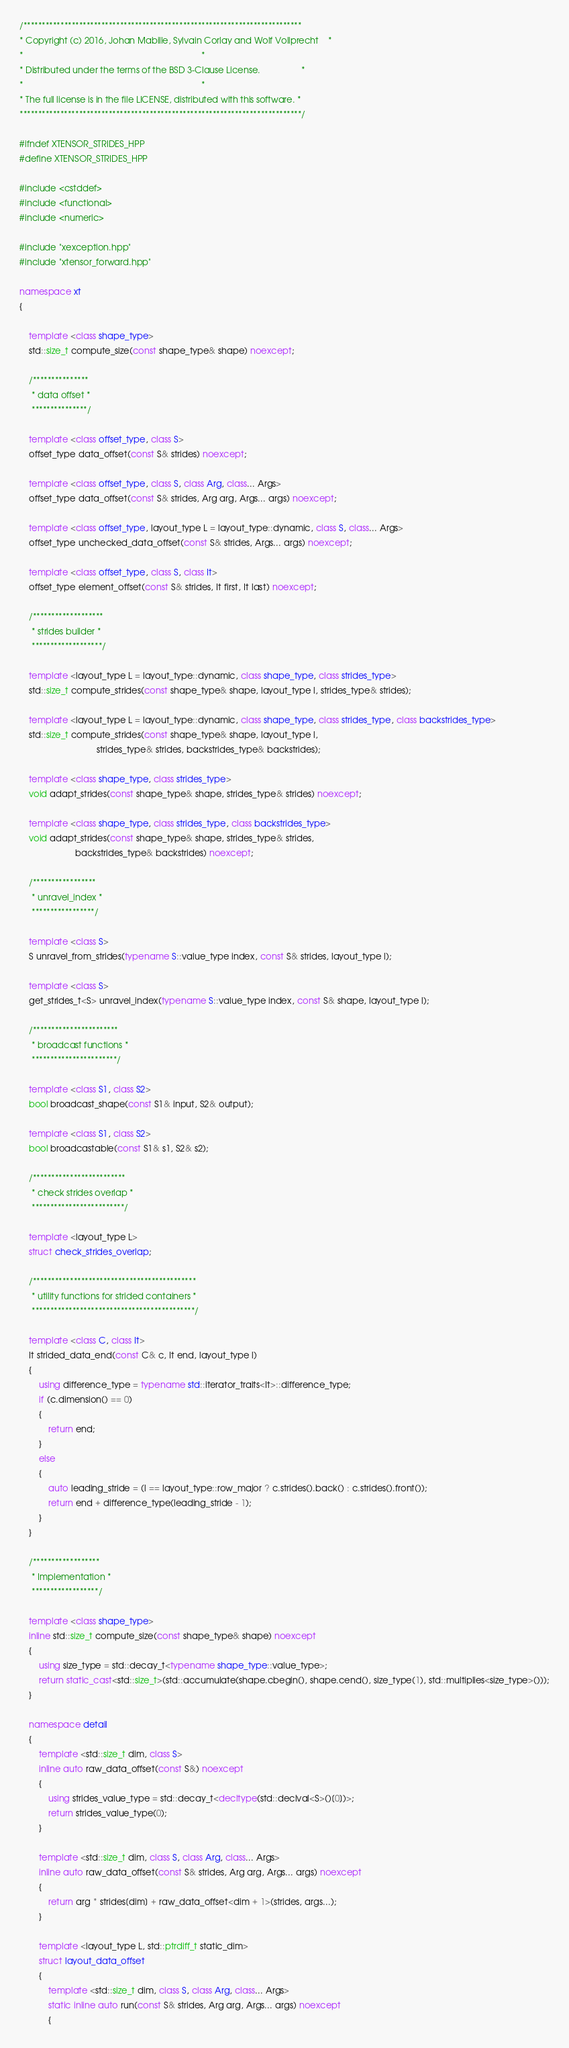Convert code to text. <code><loc_0><loc_0><loc_500><loc_500><_C++_>/***************************************************************************
* Copyright (c) 2016, Johan Mabille, Sylvain Corlay and Wolf Vollprecht    *
*                                                                          *
* Distributed under the terms of the BSD 3-Clause License.                 *
*                                                                          *
* The full license is in the file LICENSE, distributed with this software. *
****************************************************************************/

#ifndef XTENSOR_STRIDES_HPP
#define XTENSOR_STRIDES_HPP

#include <cstddef>
#include <functional>
#include <numeric>

#include "xexception.hpp"
#include "xtensor_forward.hpp"

namespace xt
{

    template <class shape_type>
    std::size_t compute_size(const shape_type& shape) noexcept;

    /***************
     * data offset *
     ***************/

    template <class offset_type, class S>
    offset_type data_offset(const S& strides) noexcept;

    template <class offset_type, class S, class Arg, class... Args>
    offset_type data_offset(const S& strides, Arg arg, Args... args) noexcept;

    template <class offset_type, layout_type L = layout_type::dynamic, class S, class... Args>
    offset_type unchecked_data_offset(const S& strides, Args... args) noexcept;

    template <class offset_type, class S, class It>
    offset_type element_offset(const S& strides, It first, It last) noexcept;

    /*******************
     * strides builder *
     *******************/

    template <layout_type L = layout_type::dynamic, class shape_type, class strides_type>
    std::size_t compute_strides(const shape_type& shape, layout_type l, strides_type& strides);

    template <layout_type L = layout_type::dynamic, class shape_type, class strides_type, class backstrides_type>
    std::size_t compute_strides(const shape_type& shape, layout_type l,
                                strides_type& strides, backstrides_type& backstrides);

    template <class shape_type, class strides_type>
    void adapt_strides(const shape_type& shape, strides_type& strides) noexcept;

    template <class shape_type, class strides_type, class backstrides_type>
    void adapt_strides(const shape_type& shape, strides_type& strides,
                       backstrides_type& backstrides) noexcept;

    /*****************
     * unravel_index *
     *****************/

    template <class S>
    S unravel_from_strides(typename S::value_type index, const S& strides, layout_type l);

    template <class S>
    get_strides_t<S> unravel_index(typename S::value_type index, const S& shape, layout_type l);

    /***********************
     * broadcast functions *
     ***********************/

    template <class S1, class S2>
    bool broadcast_shape(const S1& input, S2& output);

    template <class S1, class S2>
    bool broadcastable(const S1& s1, S2& s2);

    /*************************
     * check strides overlap *
     *************************/

    template <layout_type L>
    struct check_strides_overlap;

    /********************************************
     * utility functions for strided containers *
     ********************************************/

    template <class C, class It>
    It strided_data_end(const C& c, It end, layout_type l)
    {
        using difference_type = typename std::iterator_traits<It>::difference_type;
        if (c.dimension() == 0)
        {
            return end;
        }
        else
        {
            auto leading_stride = (l == layout_type::row_major ? c.strides().back() : c.strides().front());
            return end + difference_type(leading_stride - 1);
        }
    }

    /******************
     * Implementation *
     ******************/

    template <class shape_type>
    inline std::size_t compute_size(const shape_type& shape) noexcept
    {
        using size_type = std::decay_t<typename shape_type::value_type>;
        return static_cast<std::size_t>(std::accumulate(shape.cbegin(), shape.cend(), size_type(1), std::multiplies<size_type>()));
    }

    namespace detail
    {
        template <std::size_t dim, class S>
        inline auto raw_data_offset(const S&) noexcept
        {
            using strides_value_type = std::decay_t<decltype(std::declval<S>()[0])>;
            return strides_value_type(0);
        }

        template <std::size_t dim, class S, class Arg, class... Args>
        inline auto raw_data_offset(const S& strides, Arg arg, Args... args) noexcept
        {
            return arg * strides[dim] + raw_data_offset<dim + 1>(strides, args...);
        }

        template <layout_type L, std::ptrdiff_t static_dim>
        struct layout_data_offset
        {
            template <std::size_t dim, class S, class Arg, class... Args>
            static inline auto run(const S& strides, Arg arg, Args... args) noexcept
            {</code> 